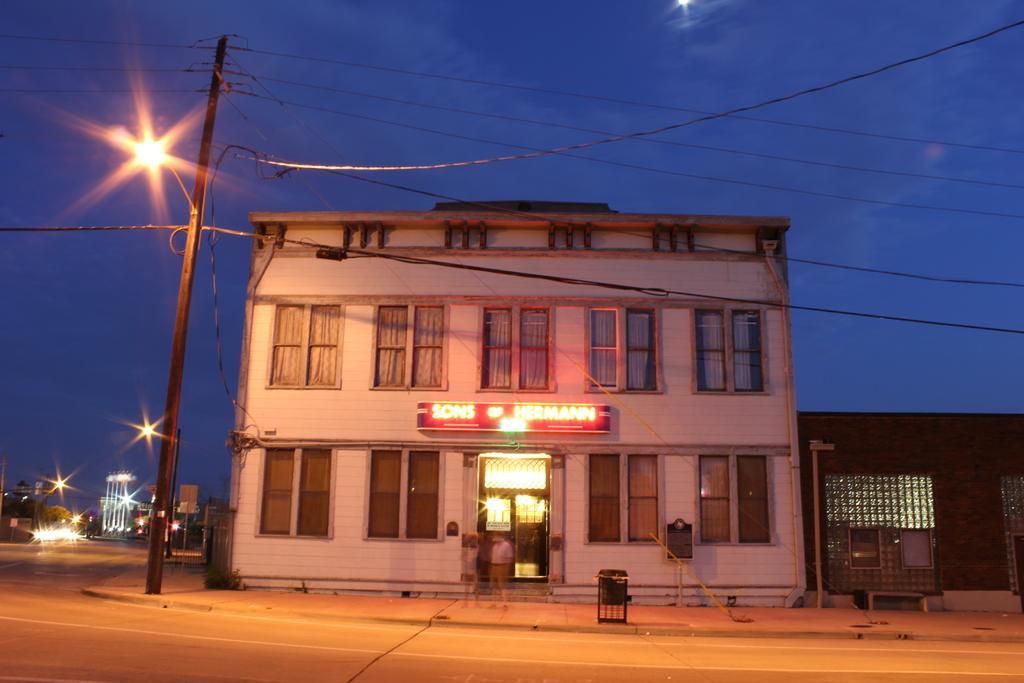Please provide a concise description of this image. In the image there is a building in the front with street lights behind it and two persons standing on the footpath in front of the road and above its sky. 